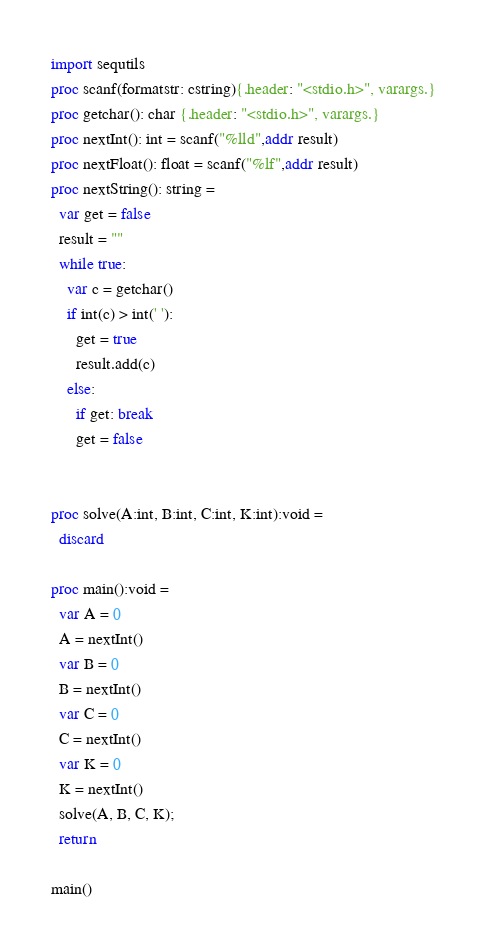<code> <loc_0><loc_0><loc_500><loc_500><_Nim_>import sequtils
proc scanf(formatstr: cstring){.header: "<stdio.h>", varargs.}
proc getchar(): char {.header: "<stdio.h>", varargs.}
proc nextInt(): int = scanf("%lld",addr result)
proc nextFloat(): float = scanf("%lf",addr result)
proc nextString(): string =
  var get = false
  result = ""
  while true:
    var c = getchar()
    if int(c) > int(' '):
      get = true
      result.add(c)
    else:
      if get: break
      get = false


proc solve(A:int, B:int, C:int, K:int):void =
  discard

proc main():void =
  var A = 0
  A = nextInt()
  var B = 0
  B = nextInt()
  var C = 0
  C = nextInt()
  var K = 0
  K = nextInt()
  solve(A, B, C, K);
  return

main()
</code> 